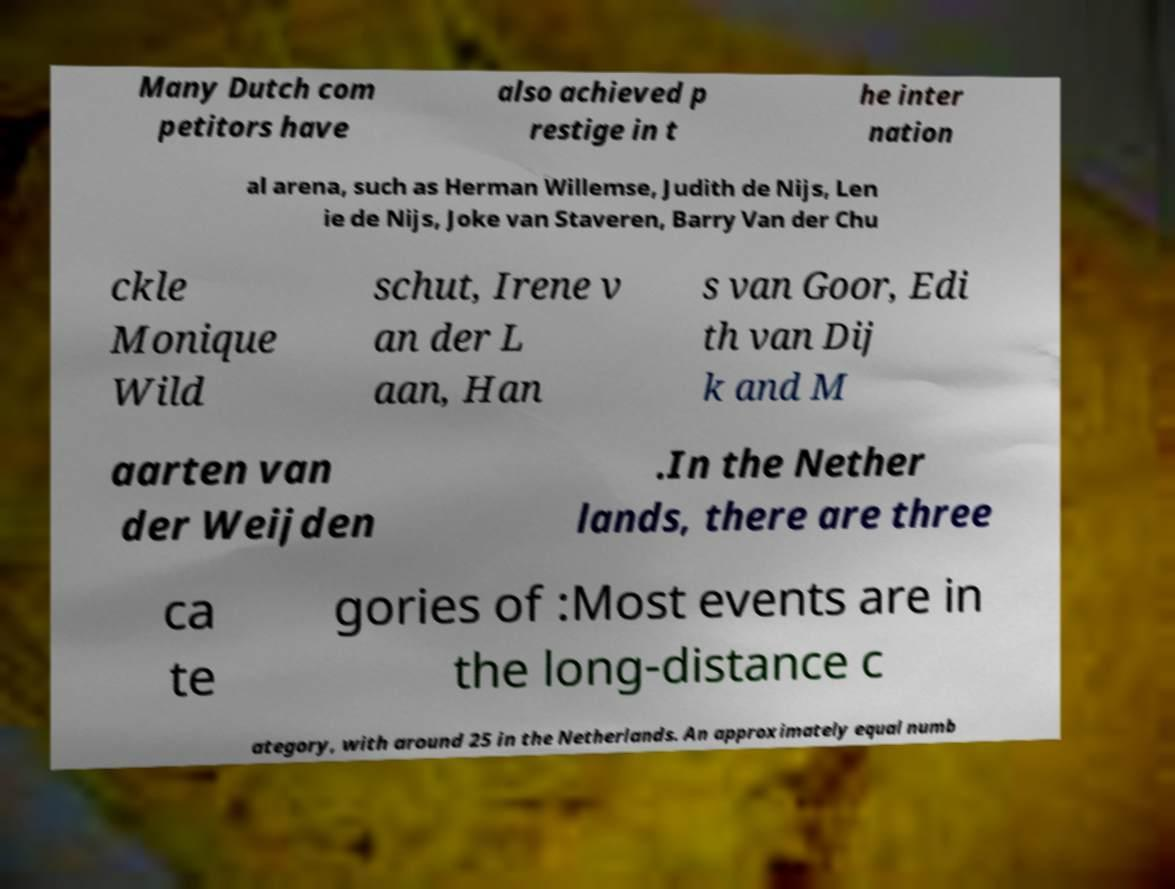I need the written content from this picture converted into text. Can you do that? Many Dutch com petitors have also achieved p restige in t he inter nation al arena, such as Herman Willemse, Judith de Nijs, Len ie de Nijs, Joke van Staveren, Barry Van der Chu ckle Monique Wild schut, Irene v an der L aan, Han s van Goor, Edi th van Dij k and M aarten van der Weijden .In the Nether lands, there are three ca te gories of :Most events are in the long-distance c ategory, with around 25 in the Netherlands. An approximately equal numb 